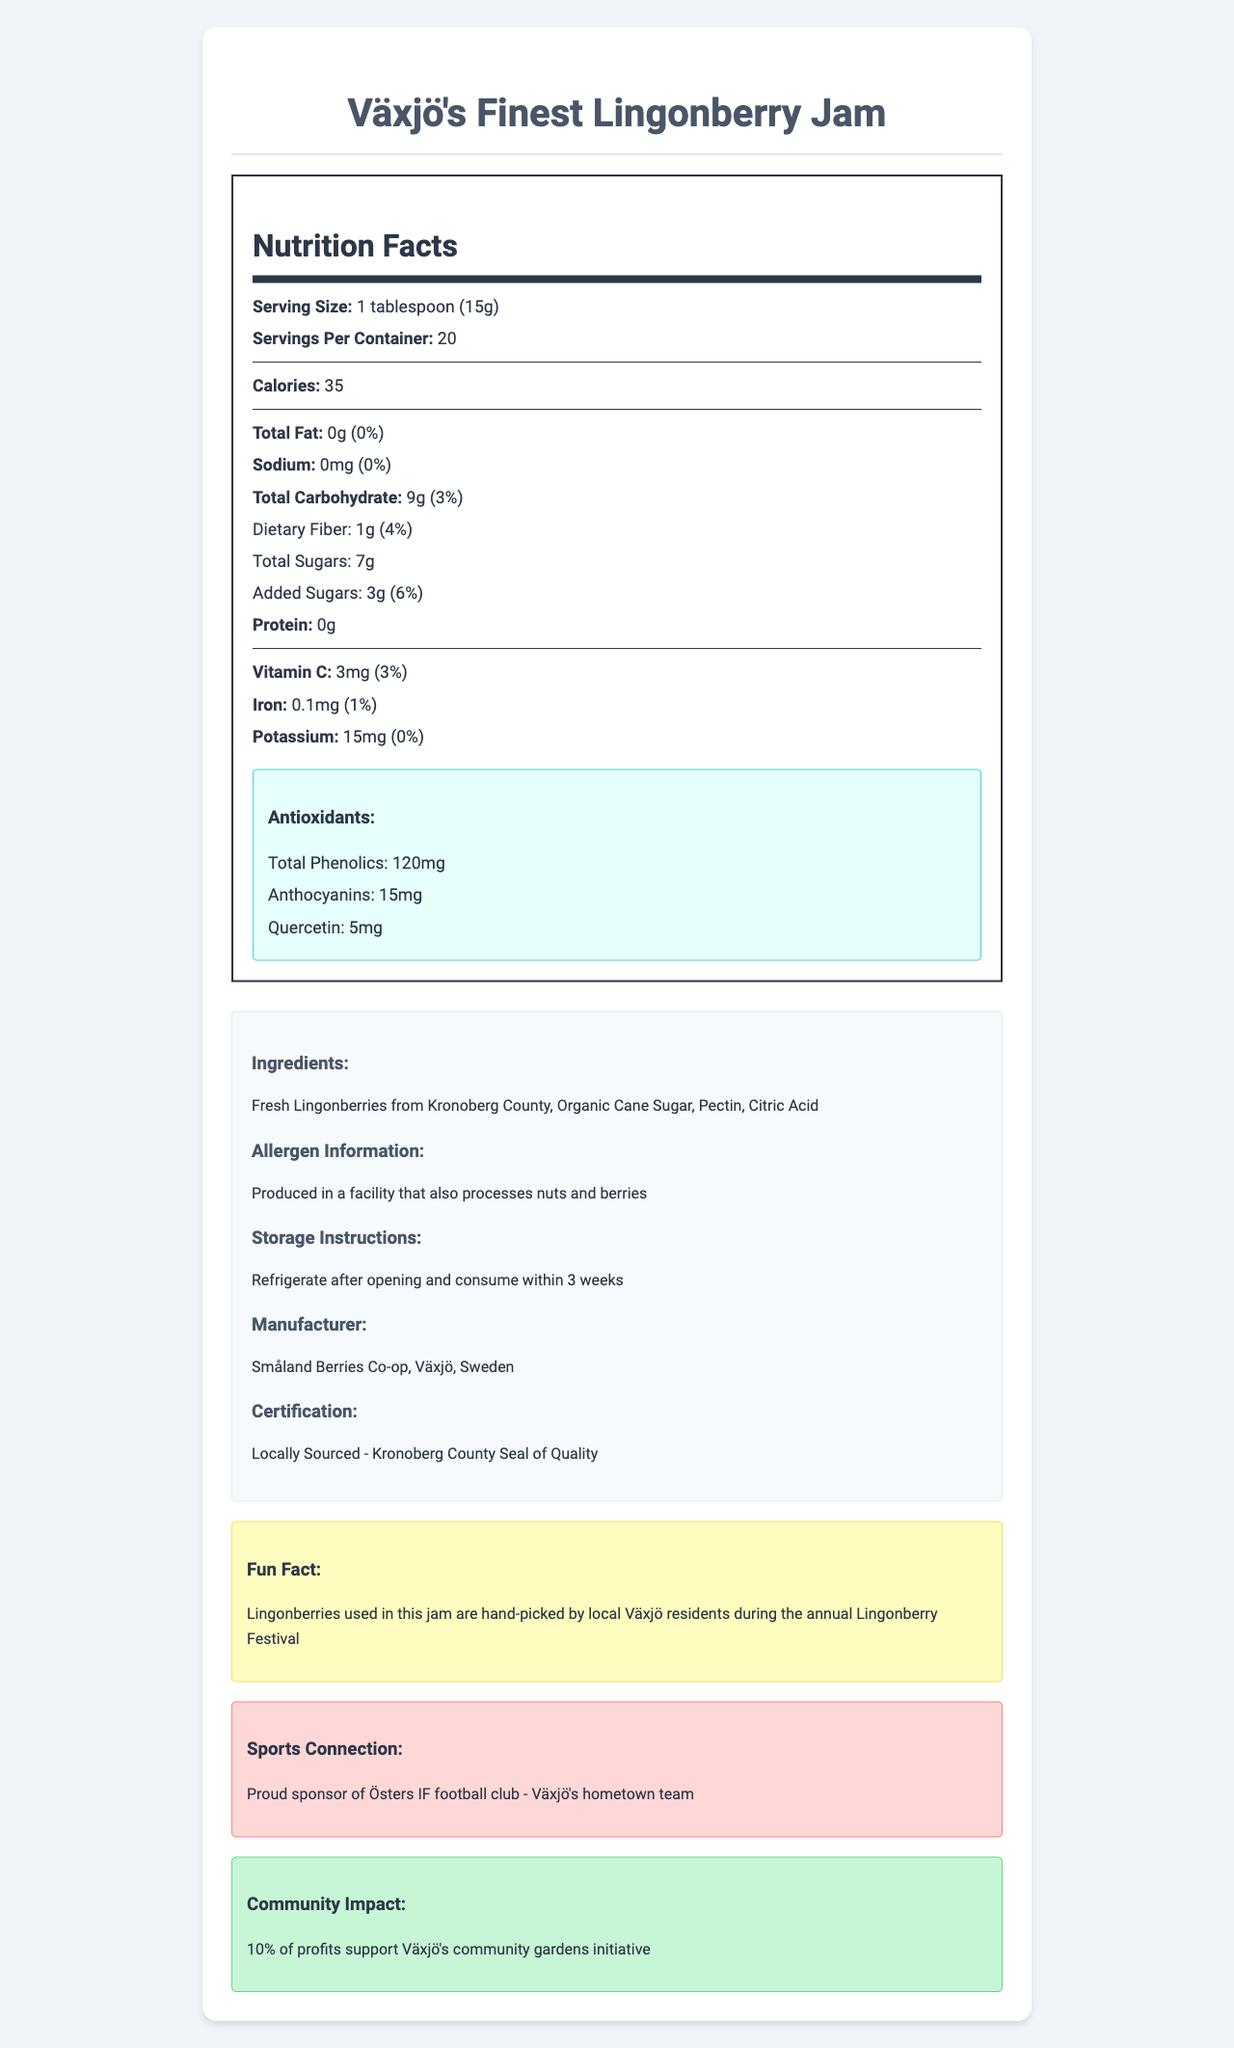what is the serving size of Växjö's Finest Lingonberry Jam? The serving size is directly listed under the Nutrition Facts as "1 tablespoon (15g)".
Answer: 1 tablespoon (15g) how many servings are there per container? The document states that there are "20 servings per container".
Answer: 20 how much total fat does one serving contain? The total fat content per serving is listed as "0g".
Answer: 0g what is the amount of dietary fiber in a serving of this jam? Dietary fiber is listed under total carbohydrate and is specified as "1g".
Answer: 1g what is the amount of vitamin C per serving and its daily value percentage? The amount of vitamin C per serving is 3mg, which is 3% of the daily value.
Answer: 3mg (3%) how much of the sugars in the jam are added sugars? The label under total sugars specifies that added sugars amount to "3g".
Answer: 3g what is the amount of total phenolics in terms of antioxidants? The total phenolics under the antioxidants section states "120mg".
Answer: 120mg which ingredient contributes to the preservation of the jam? A. Fresh Lingonberries B. Organic Cane Sugar C. Citric Acid Citric Acid is commonly used as a preservative and is listed in the ingredients.
Answer: C. Citric Acid which local community activity is supported by the profits from this jam? A. Lingonberry Festival B. Community Gardens Initiative C. Östers IF football club The document specifically mentions that 10% of profits support Växjö's community gardens initiative.
Answer: B. Community Gardens Initiative how long should the jam be consumed after opening if kept refrigerated? A. 1 week B. 2 weeks C. 3 weeks D. 1 month The storage instructions state to refrigerate after opening and consume within 3 weeks.
Answer: C. 3 weeks is the jam suitable for people with nut allergies? The allergen information states that it is produced in a facility that also processes nuts, indicating potential cross-contamination.
Answer: No what is the main idea of the document? The main idea is to inform about the nutritional value, ingredients, local sourcing, community impact, and health benefits of the lingonberry jam.
Answer: The document provides comprehensive nutritional information on Växjö's Finest Lingonberry Jam, highlights the local sourcing and community support aspects, and underscores its antioxidant content. what health benefits can be attributed to the antioxidants in the jam? The document lists the types and amounts of antioxidants but does not elaborate on specific health benefits.
Answer: Cannot be determined what local event are the lingonberries used in the jam harvested from? The fun fact section mentions that the lingonberries are hand-picked during the annual Lingonberry Festival.
Answer: Lingonberry Festival what local sports team is sponsored by the makers of this jam? The sports connection section mentions that the jam is a proud sponsor of Östers IF football club.
Answer: Östers IF football club 